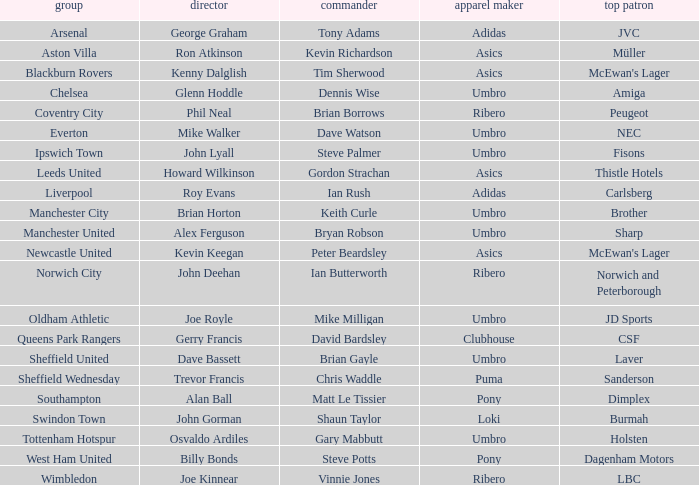What is the kit manufacturer that has billy bonds as the manager? Pony. 